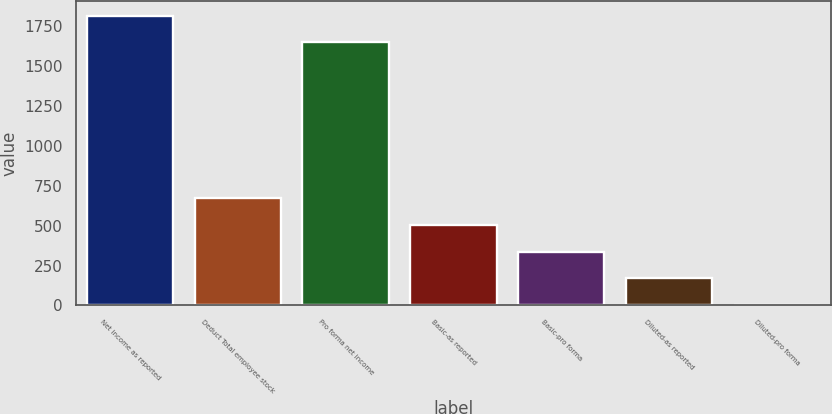<chart> <loc_0><loc_0><loc_500><loc_500><bar_chart><fcel>Net income as reported<fcel>Deduct Total employee stock<fcel>Pro forma net income<fcel>Basic-as reported<fcel>Basic-pro forma<fcel>Diluted-as reported<fcel>Diluted-pro forma<nl><fcel>1815.07<fcel>671.54<fcel>1648<fcel>504.47<fcel>337.4<fcel>170.33<fcel>3.26<nl></chart> 